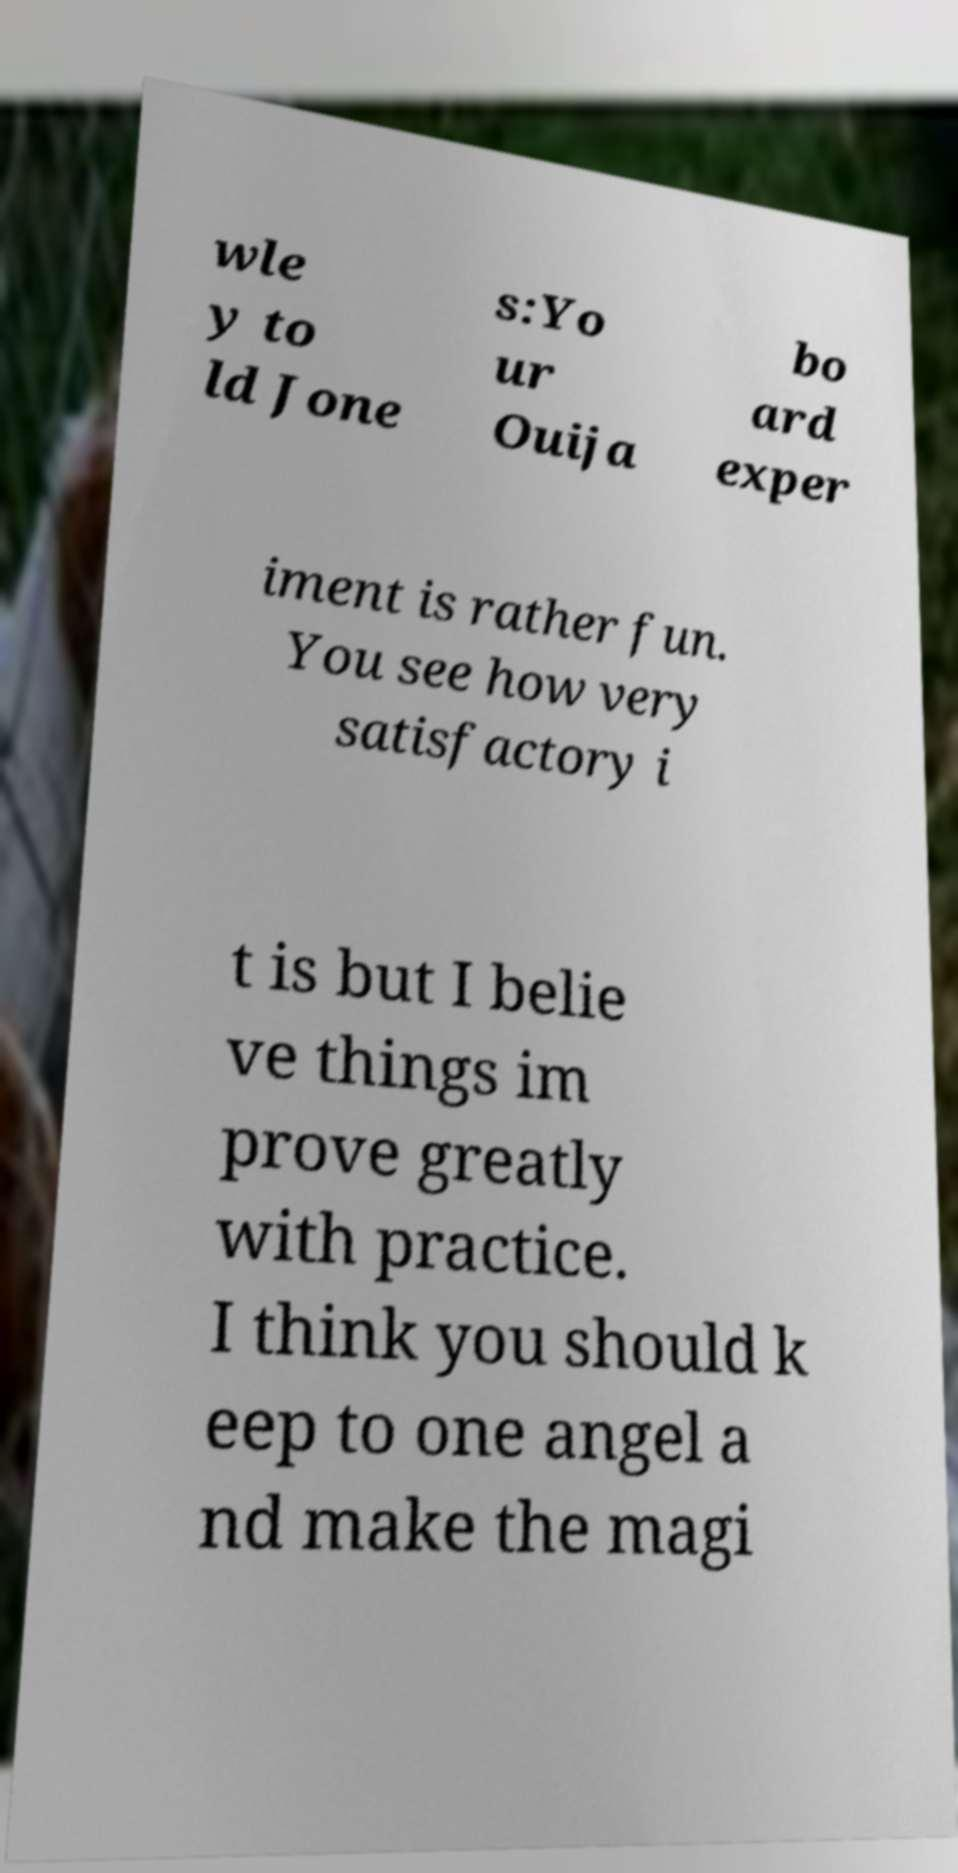For documentation purposes, I need the text within this image transcribed. Could you provide that? wle y to ld Jone s:Yo ur Ouija bo ard exper iment is rather fun. You see how very satisfactory i t is but I belie ve things im prove greatly with practice. I think you should k eep to one angel a nd make the magi 